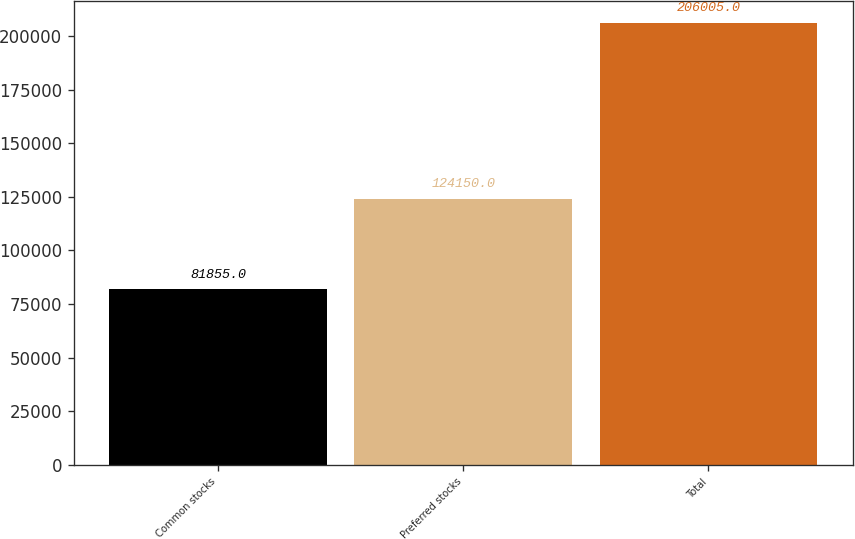Convert chart to OTSL. <chart><loc_0><loc_0><loc_500><loc_500><bar_chart><fcel>Common stocks<fcel>Preferred stocks<fcel>Total<nl><fcel>81855<fcel>124150<fcel>206005<nl></chart> 